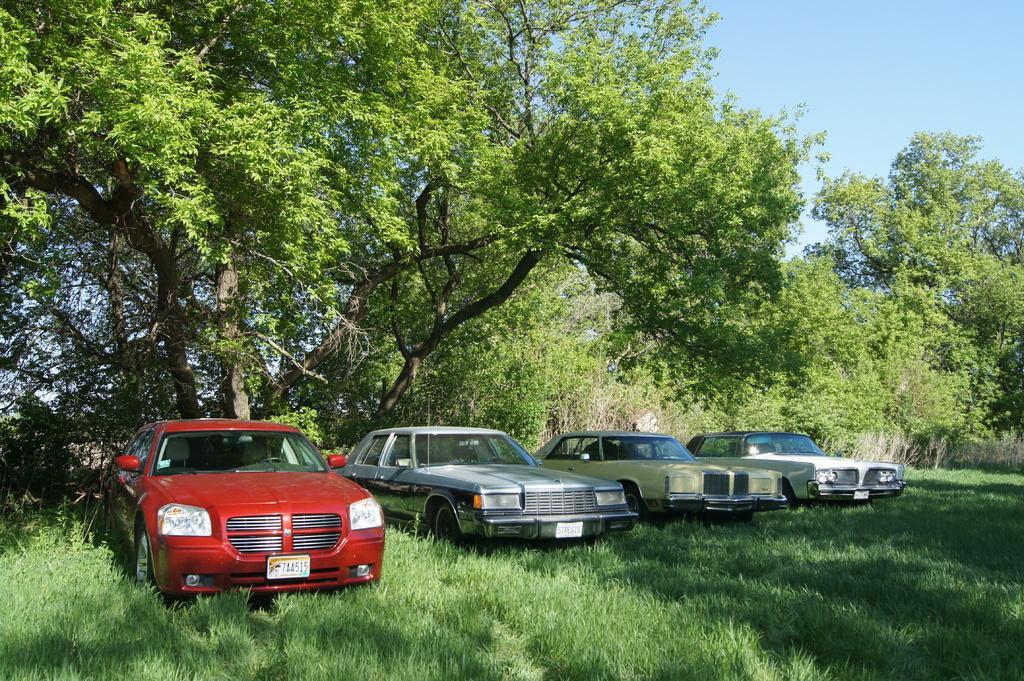Describe this image in one or two sentences. There are four cars, which are parked. These are the trees with branches and leaves. I can see the grass, which is green in color. This is the sky. 